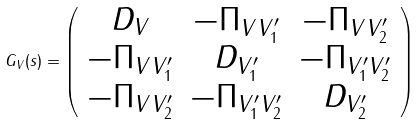Convert formula to latex. <formula><loc_0><loc_0><loc_500><loc_500>G _ { V } ( s ) = \left ( \begin{array} { c c c } { { D _ { V } } } & { { - \Pi _ { V V _ { 1 } ^ { \prime } } } } & { { - \Pi _ { V V _ { 2 } ^ { \prime } } } } \\ { { - \Pi _ { V V _ { 1 } ^ { \prime } } } } & { { D _ { V _ { 1 } ^ { \prime } } } } & { { - \Pi _ { V _ { 1 } ^ { \prime } V _ { 2 } ^ { \prime } } } } \\ { { - \Pi _ { V V _ { 2 } ^ { \prime } } } } & { { - \Pi _ { V _ { 1 } ^ { \prime } V _ { 2 } ^ { \prime } } } } & { { D _ { V _ { 2 } ^ { \prime } } } } \end{array} \right ) \,</formula> 